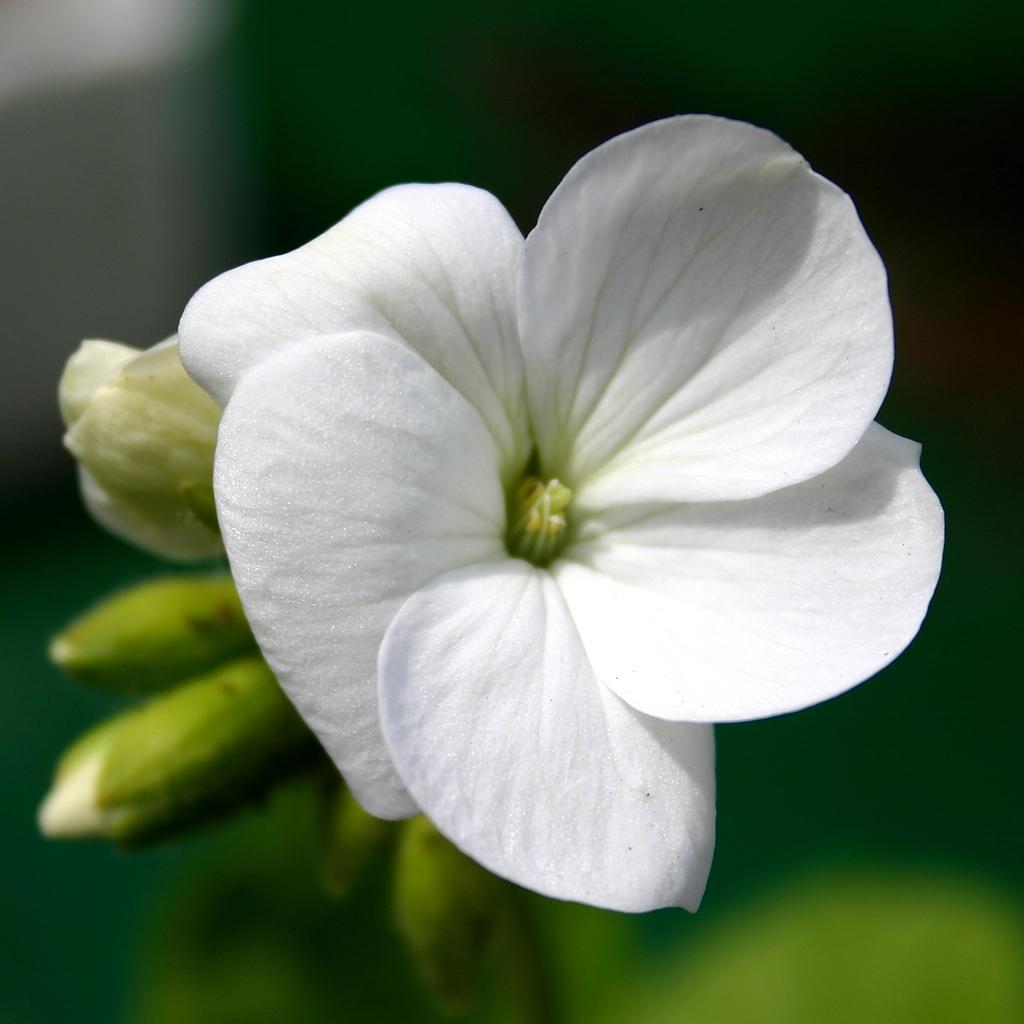Describe this image in one or two sentences. In this image we can see flowers and buds. In the background it is blur. 